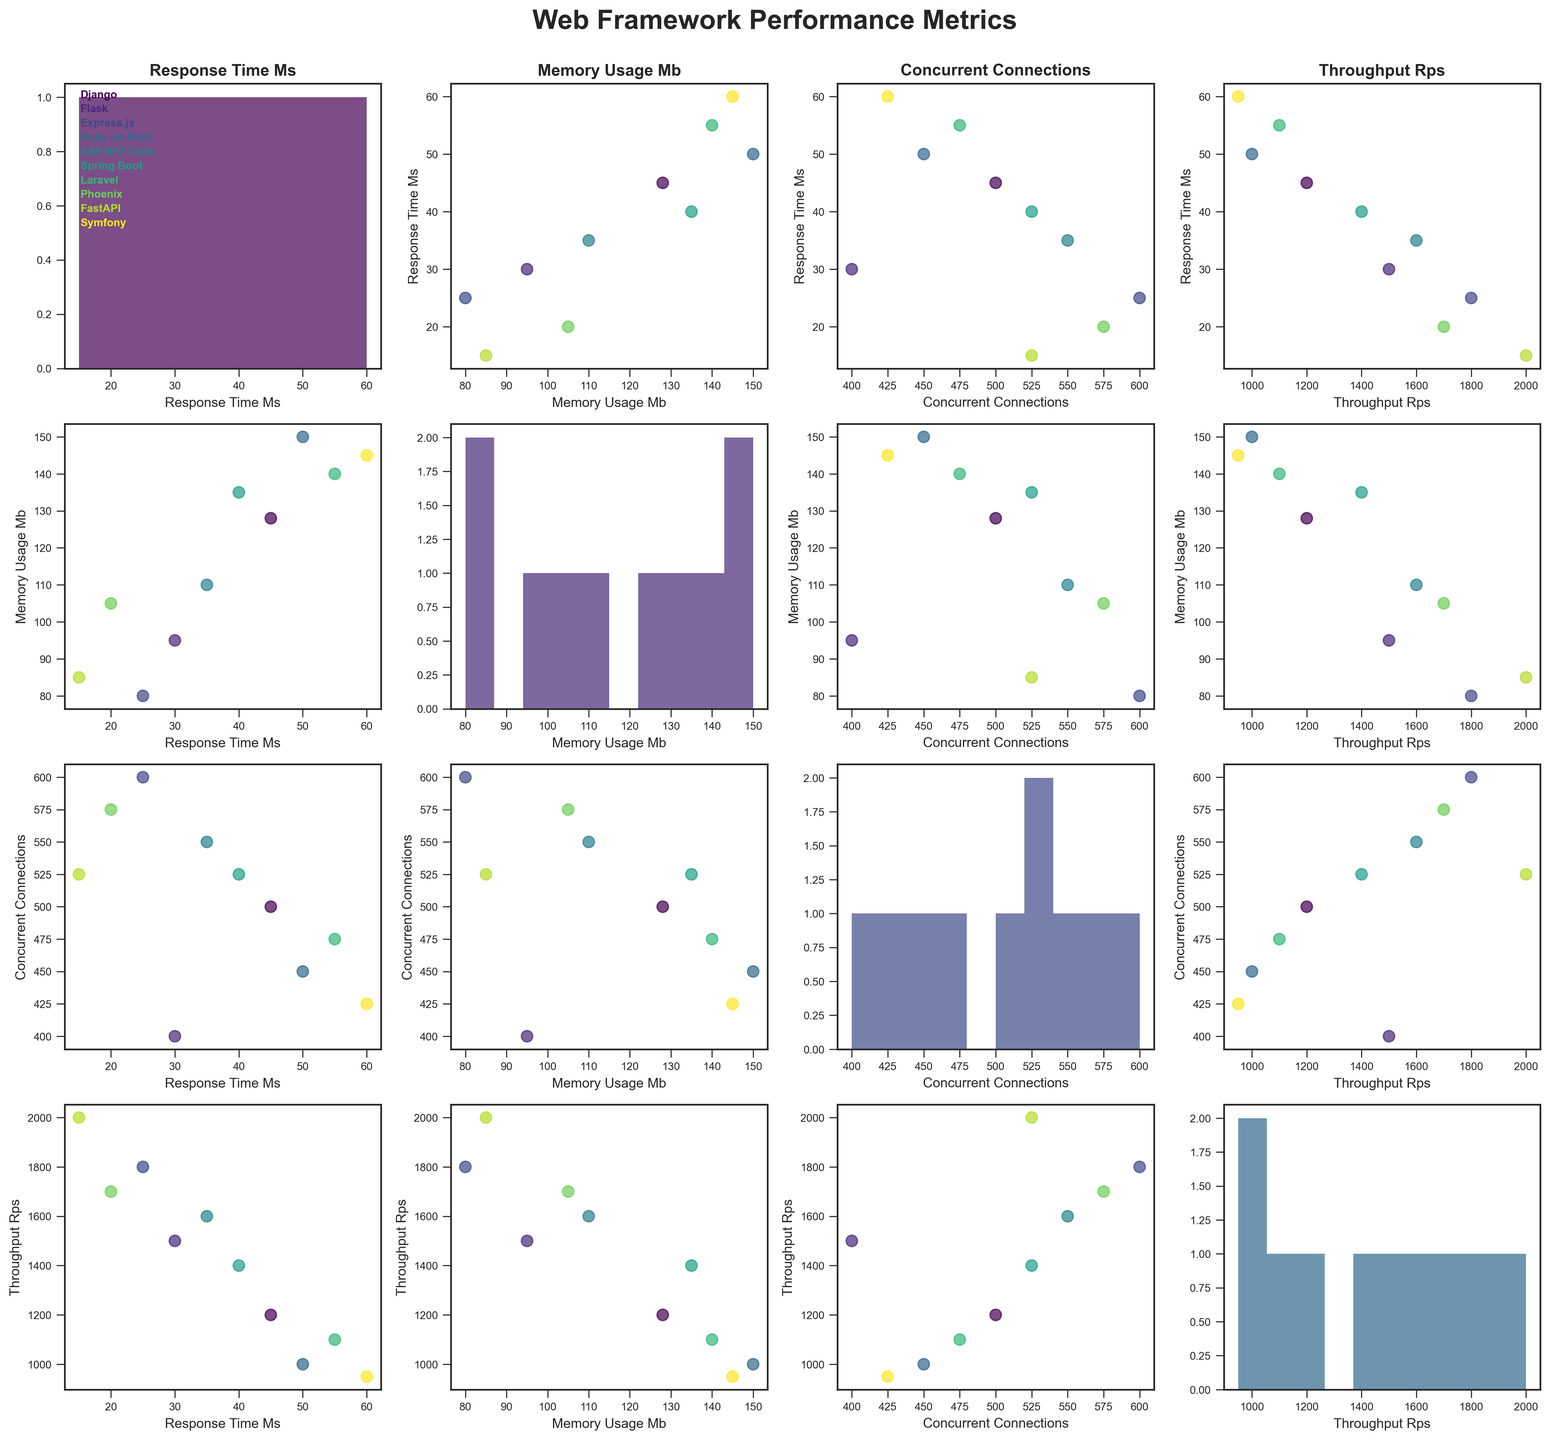What's the title of the figure? The title of the figure is usually displayed at the top center of the plot. In this case, it is written in bold, large font.
Answer: Web Framework Performance Metrics Which framework has the lowest response time? By examining the scatterplots and the histograms, FastAPI is visualized to have the lowest value in the response_time_ms histogram.
Answer: FastAPI How many metrics are compared in the scatterplot matrix? The figure compares four metrics, which can be identified by counting the unique labels on the axes of the scatterplot matrix.
Answer: Four Which metric seems to have the highest variance in values across the frameworks? By observing the spread of values in the histograms along the diagonal, the "throughput_rps" histogram shows the widest spread of values.
Answer: throughput_rps Compare Flask and Django in terms of concurrent connections. Which one supports more connections, and by how much? Locate Flask and Django on the concurrent_connections axes. Flask is at 400 connections, and Django is at 500 connections. The difference is 500 - 400.
Answer: Django by 100 Is there any framework that consistently uses higher memory compared to others? By looking at the scatter plots involving memory_usage_mb, the vertical spread of points indicates that Ruby on Rails, Laravel, and Symfony tend to use higher memory consistently.
Answer: Yes What is the general trend between response time and throughput? Observing the scatterplot for response_time_ms vs throughput_rps, a general trend shows that as the response_time_ms decreases, throughput_rps increases, indicating an inverse relationship.
Answer: Inverse Does higher memory usage correlate with higher throughput? Observing the scatterplot of memory_usage_mb vs throughput_rps, there is no clear linear trend suggesting that higher memory usage directly correlates with higher throughput.
Answer: No Which framework has the highest throughput and what other metrics accompany this framework? Checking the highest point on the throughput_rps axis, FastAPI is identified as the framework with the highest throughput (2000 rps). The accompanying metrics are 15 ms response time, 85 MB memory usage, and 525 concurrent connections.
Answer: FastAPI: 15 ms response time, 85 MB memory, 525 connections 